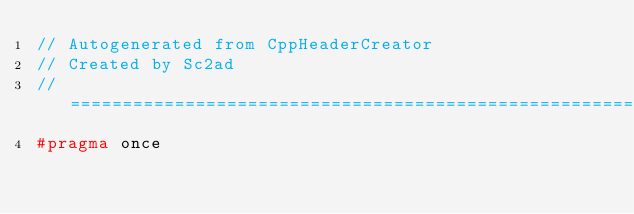<code> <loc_0><loc_0><loc_500><loc_500><_C++_>// Autogenerated from CppHeaderCreator
// Created by Sc2ad
// =========================================================================
#pragma once</code> 